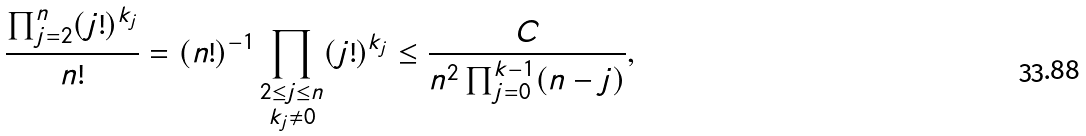<formula> <loc_0><loc_0><loc_500><loc_500>\frac { \prod _ { j = 2 } ^ { n } ( j ! ) ^ { k _ { j } } } { n ! } = ( n ! ) ^ { - 1 } \prod _ { \substack { 2 \leq j \leq n \\ k _ { j } \neq 0 } } ( j ! ) ^ { k _ { j } } \leq \frac { C } { n ^ { 2 } \prod _ { j = 0 } ^ { k - 1 } ( n - j ) } ,</formula> 